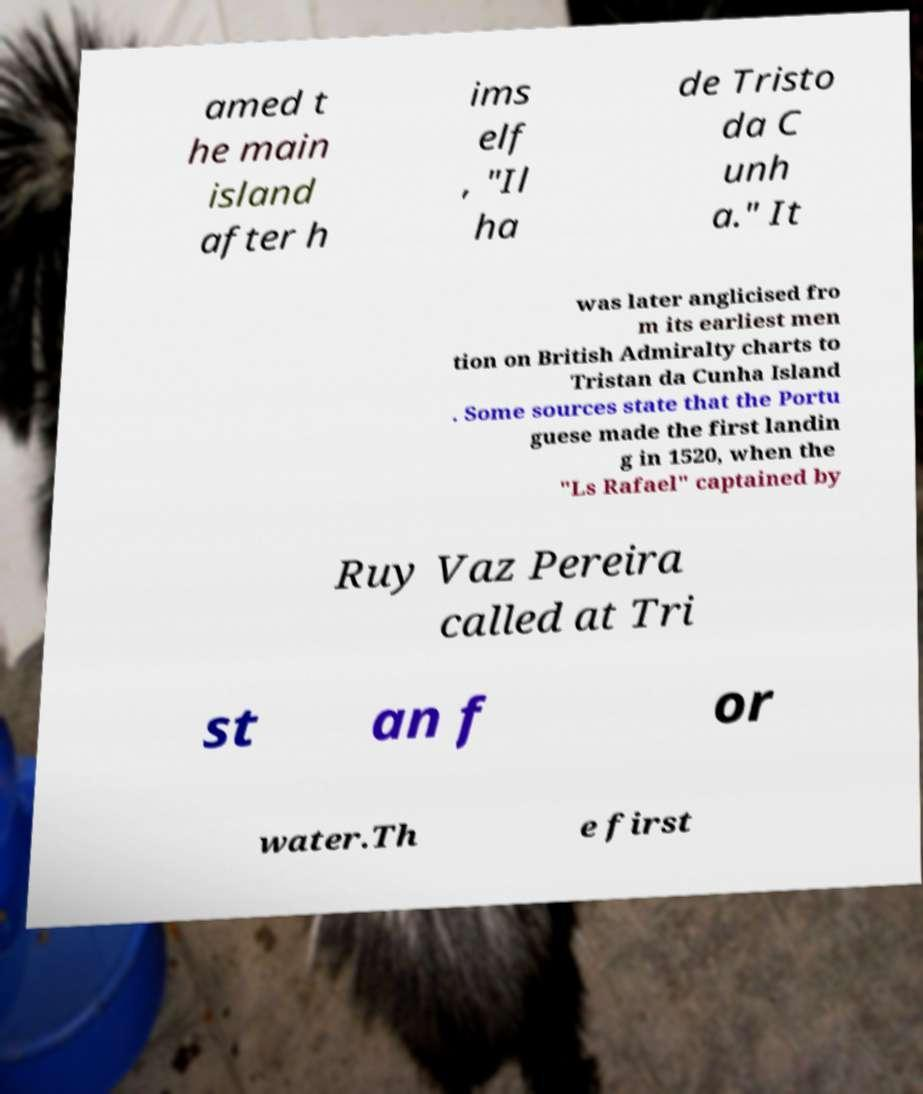I need the written content from this picture converted into text. Can you do that? amed t he main island after h ims elf , "Il ha de Tristo da C unh a." It was later anglicised fro m its earliest men tion on British Admiralty charts to Tristan da Cunha Island . Some sources state that the Portu guese made the first landin g in 1520, when the "Ls Rafael" captained by Ruy Vaz Pereira called at Tri st an f or water.Th e first 